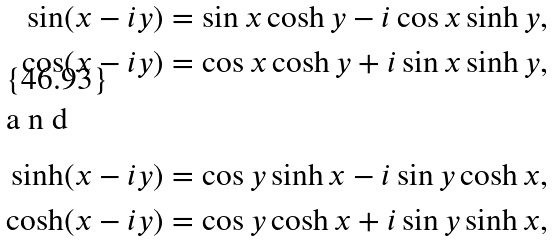Convert formula to latex. <formula><loc_0><loc_0><loc_500><loc_500>\sin ( x - i y ) & = \sin x \cosh y - i \cos x \sinh y , \\ \cos ( x - i y ) & = \cos x \cosh y + i \sin x \sinh y , \\ \intertext { a n d } \sinh ( x - i y ) & = \cos y \sinh x - i \sin y \cosh x , \\ \cosh ( x - i y ) & = \cos y \cosh x + i \sin y \sinh x ,</formula> 